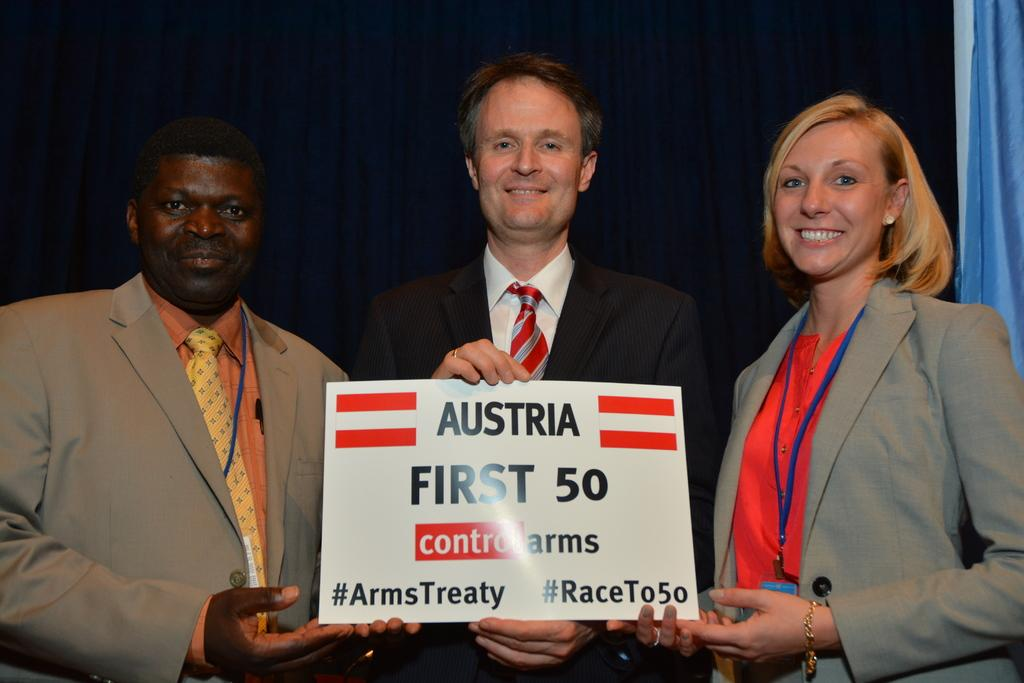How many people are in the image? There are three persons standing in the middle of the image. What are the people doing in the image? The persons are smiling and holding a banner. Can you describe the banner in the image? Unfortunately, the facts provided do not give any details about the banner. What can be seen in the background of the image? There are clothes visible in the background of the image. What type of toe is visible on the person's foot in the image? There is no toe visible in the image, as the persons are standing and holding a banner. 